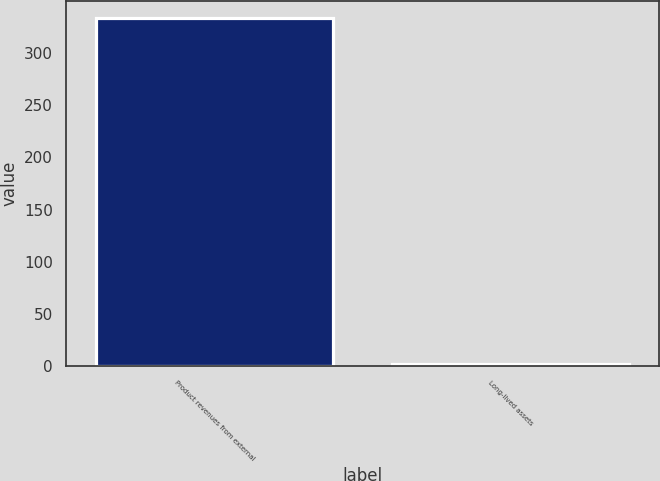Convert chart. <chart><loc_0><loc_0><loc_500><loc_500><bar_chart><fcel>Product revenues from external<fcel>Long-lived assets<nl><fcel>333.3<fcel>1.7<nl></chart> 